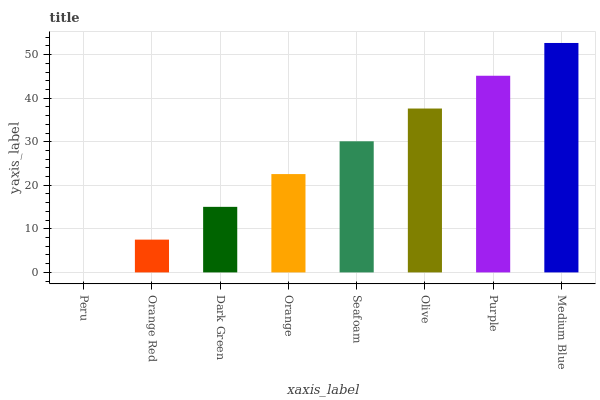Is Peru the minimum?
Answer yes or no. Yes. Is Medium Blue the maximum?
Answer yes or no. Yes. Is Orange Red the minimum?
Answer yes or no. No. Is Orange Red the maximum?
Answer yes or no. No. Is Orange Red greater than Peru?
Answer yes or no. Yes. Is Peru less than Orange Red?
Answer yes or no. Yes. Is Peru greater than Orange Red?
Answer yes or no. No. Is Orange Red less than Peru?
Answer yes or no. No. Is Seafoam the high median?
Answer yes or no. Yes. Is Orange the low median?
Answer yes or no. Yes. Is Dark Green the high median?
Answer yes or no. No. Is Seafoam the low median?
Answer yes or no. No. 